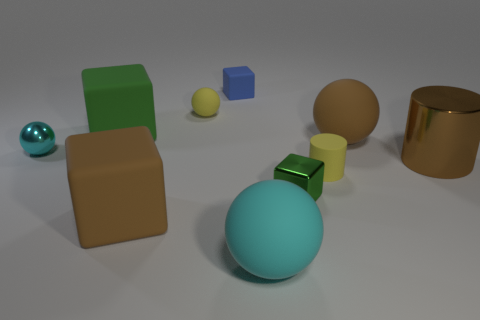Subtract 1 balls. How many balls are left? 3 Subtract all cylinders. How many objects are left? 8 Add 6 tiny purple metallic cylinders. How many tiny purple metallic cylinders exist? 6 Subtract 1 blue blocks. How many objects are left? 9 Subtract all big brown cubes. Subtract all tiny yellow balls. How many objects are left? 8 Add 6 tiny green things. How many tiny green things are left? 7 